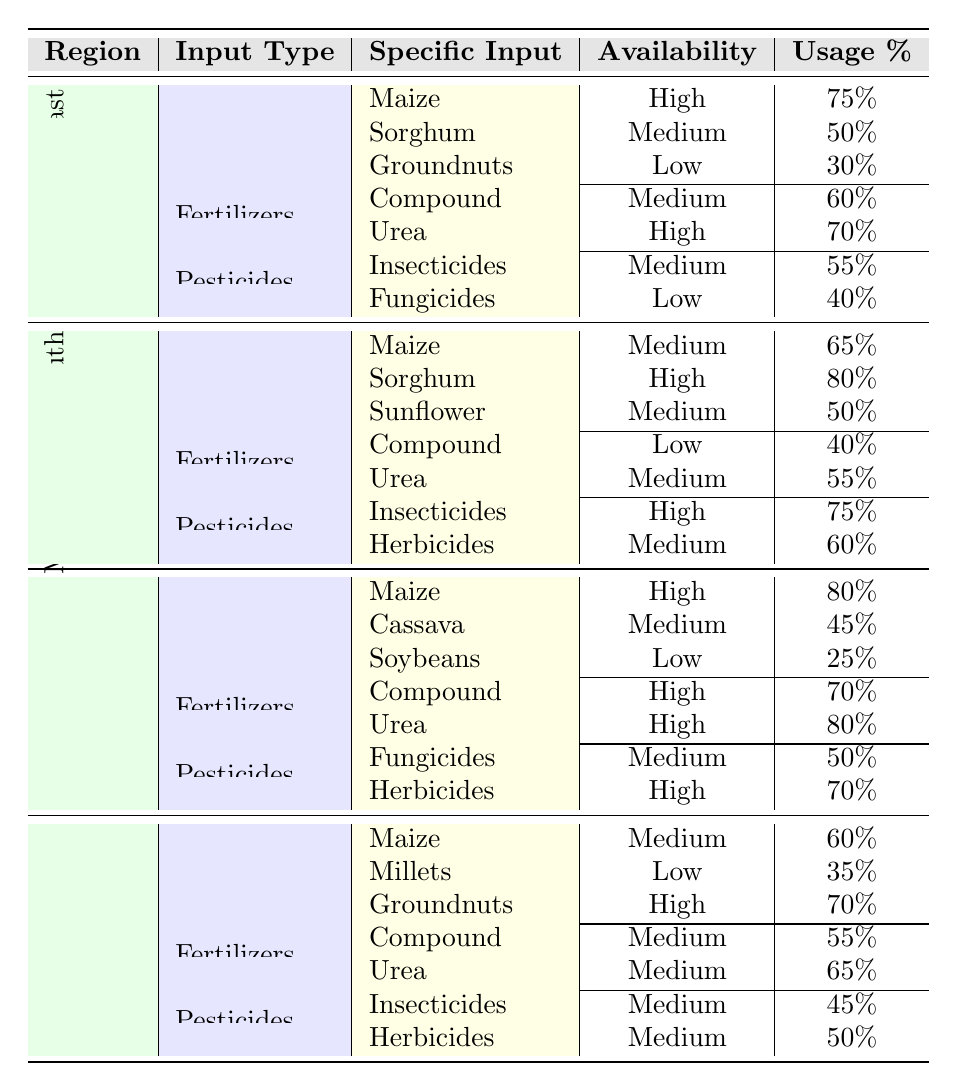What is the availability of maize seeds in Manicaland? The table shows that for Manicaland, the row under the seeds section indicates that the availability for maize is high.
Answer: High Which region has the highest usage percentage of sorghum seeds? Looking at the seeds section for sorghum across all regions, Matebeleland South has the highest usage percentage of 80%.
Answer: Matebeleland South Are herbicides available in the Midlands region? The table includes the pesticides section for Midlands, indicating that herbicides are marked as medium availability. Thus, the answer is yes.
Answer: Yes What is the average usage percentage of urea fertilizers across the regions? The usage percentages for urea fertilizers are 70% (Mashonaland East), 55% (Matebeleland South), 80% (Manicaland), and 65% (Midlands). Adding them gives 70 + 55 + 80 + 65 = 270, and dividing by 4 gives an average of 67.5%.
Answer: 67.5% Which pesticide has the lowest availability in Mashonaland East? By checking the pesticides section for Mashonaland East, we see that fungicides have a low availability while insecticides are medium. Thus, the answer is fungicides.
Answer: Fungicides Is the availability of fertilizers labeled as high in Matebeleland South? The fertilizers section for Matebeleland South reveals that the compound fertilizer is low while urea is medium, indicating that there is no high availability.
Answer: No Which region has a high usage percentage for both maize and groundnuts seeds? By examining the seeds section, Manicaland shows high usage percentages with 80% for maize and 70% for groundnuts, suggesting that it meets the criteria for both.
Answer: Manicaland What is the difference in availability between sunflower seeds in Matebeleland South and groundnuts seeds in Mashonaland East? From the seeds section, sunflower availability in Matebeleland South is medium, while groundnuts availability in Mashonaland East is low. This is a difference of one category, from medium to low availability.
Answer: One category difference How many types of pesticides are listed for the Midlands region? The pesticides section for Midlands includes insecticides and herbicides, making a total of two types of pesticides available.
Answer: 2 